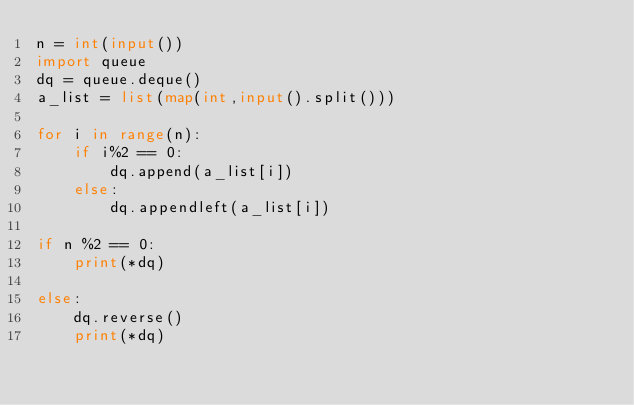Convert code to text. <code><loc_0><loc_0><loc_500><loc_500><_Python_>n = int(input())
import queue
dq = queue.deque()
a_list = list(map(int,input().split()))

for i in range(n):
    if i%2 == 0:
        dq.append(a_list[i])
    else:
        dq.appendleft(a_list[i])
        
if n %2 == 0:
    print(*dq)
    
else:
    dq.reverse()
    print(*dq)</code> 